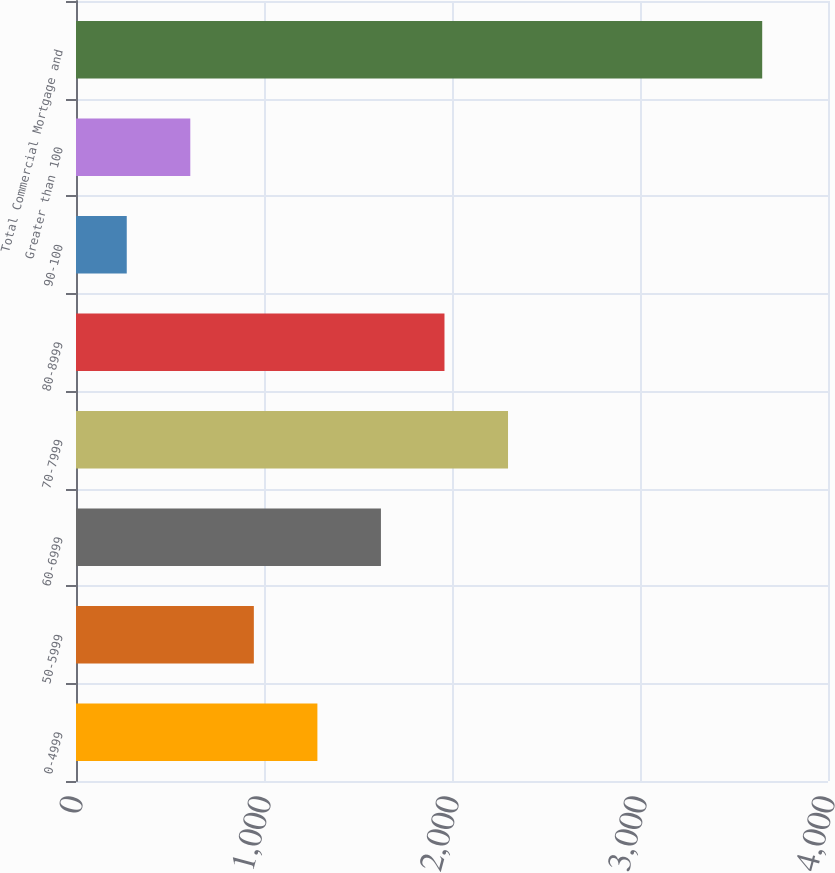<chart> <loc_0><loc_0><loc_500><loc_500><bar_chart><fcel>0-4999<fcel>50-5999<fcel>60-6999<fcel>70-7999<fcel>80-8999<fcel>90-100<fcel>Greater than 100<fcel>Total Commercial Mortgage and<nl><fcel>1284<fcel>946<fcel>1622<fcel>2298<fcel>1960<fcel>270<fcel>608<fcel>3650<nl></chart> 